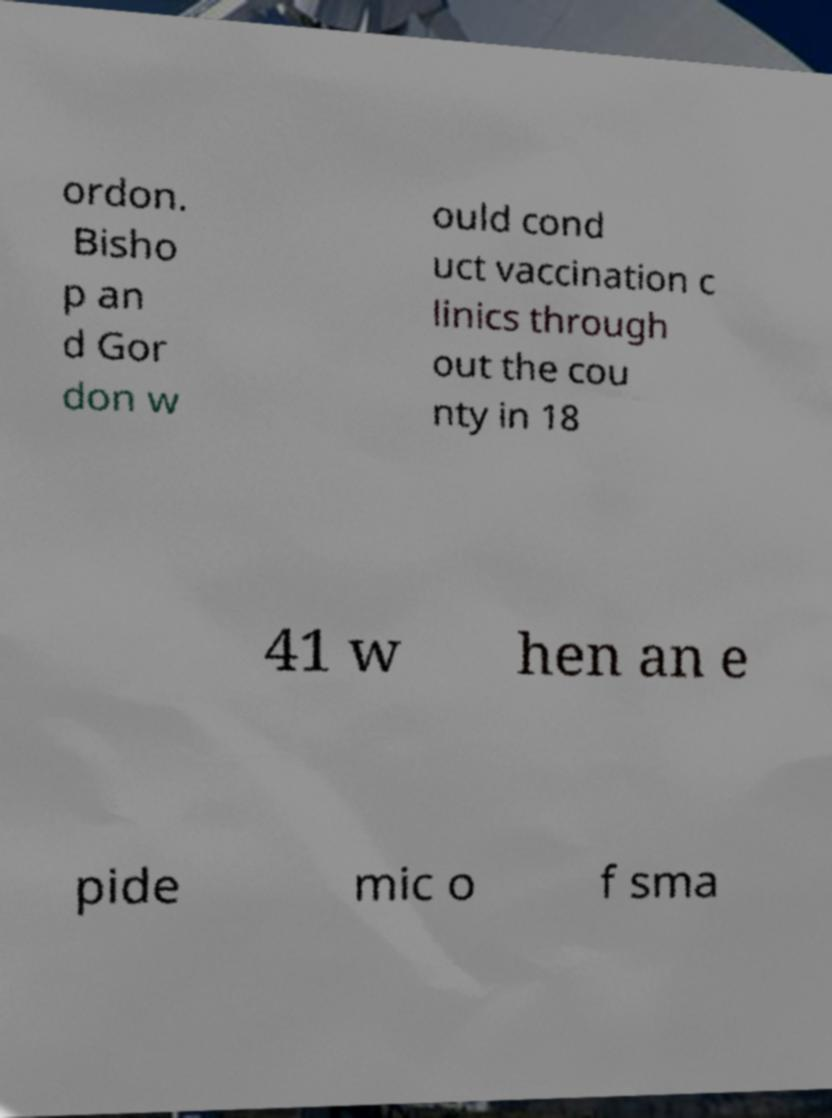Could you extract and type out the text from this image? ordon. Bisho p an d Gor don w ould cond uct vaccination c linics through out the cou nty in 18 41 w hen an e pide mic o f sma 